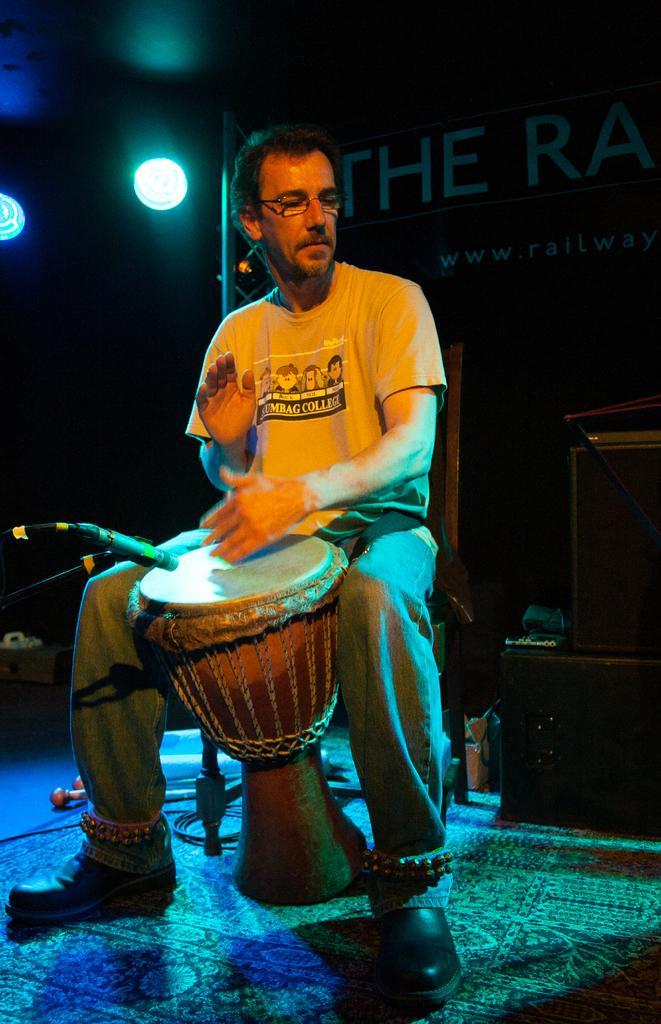How would you summarize this image in a sentence or two? Here is a man sitting and playing a musical instrument. This is a mike with a mike stand. At background I can see a banner with some name on it. And these are some objects which are black in color. 